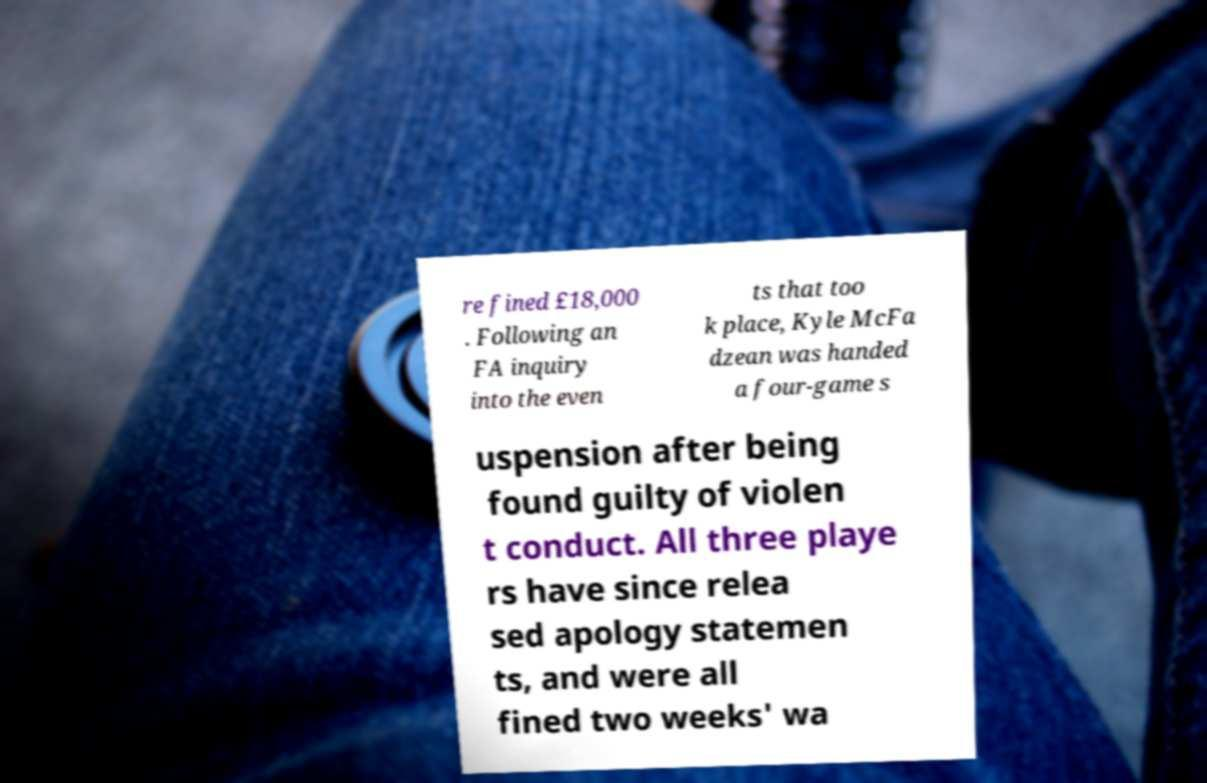Can you read and provide the text displayed in the image?This photo seems to have some interesting text. Can you extract and type it out for me? re fined £18,000 . Following an FA inquiry into the even ts that too k place, Kyle McFa dzean was handed a four-game s uspension after being found guilty of violen t conduct. All three playe rs have since relea sed apology statemen ts, and were all fined two weeks' wa 